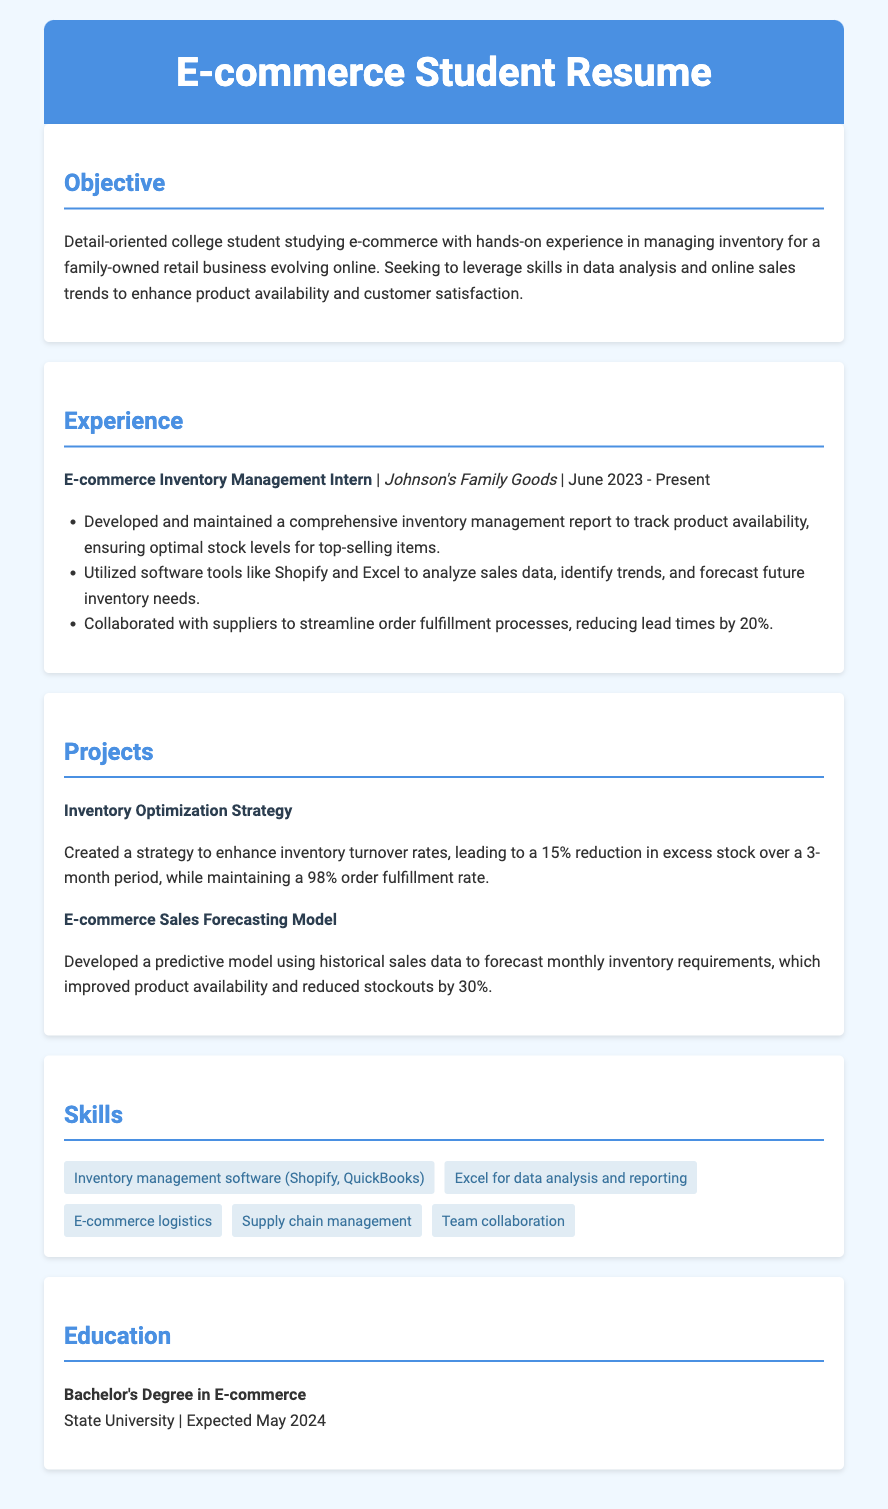what is the title of the resume? The title of the resume is provided in the header section, which reflects the individual's focus area.
Answer: E-commerce Student Resume what is the name of the current employer? The current employer is listed under the experience section, identifying where the internship takes place.
Answer: Johnson's Family Goods when did the internship start? The start date of the internship is mentioned in conjunction with the employer's name, providing a timeline.
Answer: June 2023 what was the reduction in lead times achieved through supplier collaboration? The specific percentage of lead time reduction is detailed in the experience section, indicating the impact of the effort.
Answer: 20% which project resulted in a 15% reduction in excess stock? The project title provided in the projects section highlights a specific achievement related to inventory.
Answer: Inventory Optimization Strategy what skill is emphasized for use in data analysis? A specific skill related to data analysis is listed among the skills, showcasing the individual's capabilities in that area.
Answer: Excel for data analysis and reporting how much did stockouts reduce by utilizing the sales forecasting model? The document outlines the effect of a particular project on inventory management in terms of stockouts.
Answer: 30% what is the expected graduation date? The expected graduation date is mentioned in the education section, providing a timeline for the individual’s academic career.
Answer: May 2024 which software is used for inventory management according to the skills section? The skills section lists software relevant to inventory management, indicating tools familiar to the individual.
Answer: Shopify, QuickBooks 